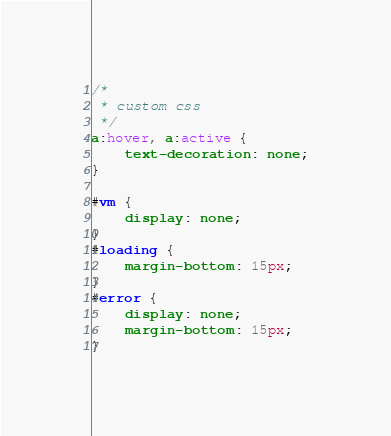Convert code to text. <code><loc_0><loc_0><loc_500><loc_500><_CSS_>/*
 * custom css
 */
a:hover, a:active {
    text-decoration: none;
}

#vm {
    display: none;
}
#loading {
    margin-bottom: 15px;
}
#error {
    display: none;
    margin-bottom: 15px;
}
</code> 